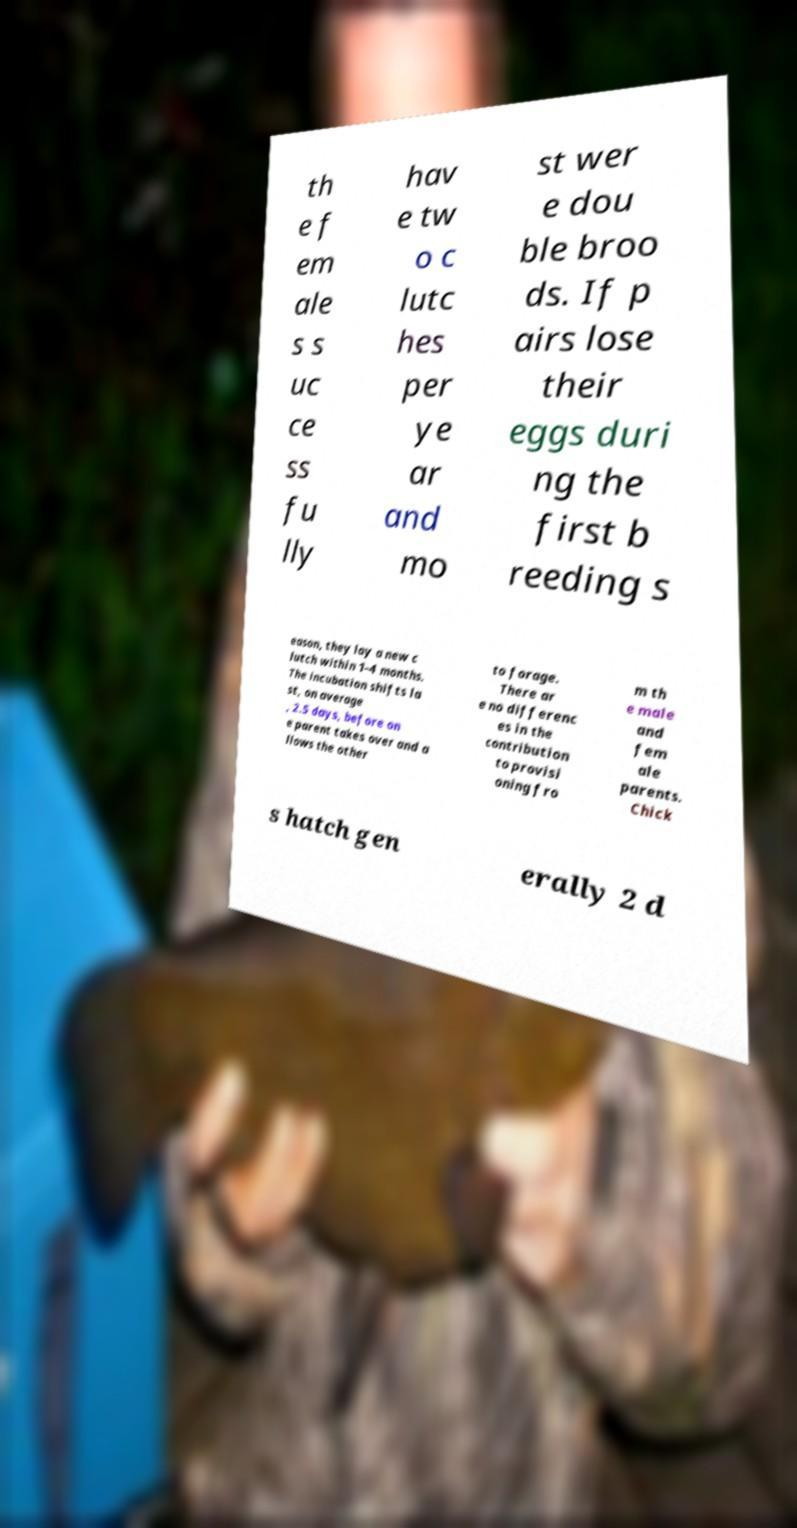What messages or text are displayed in this image? I need them in a readable, typed format. th e f em ale s s uc ce ss fu lly hav e tw o c lutc hes per ye ar and mo st wer e dou ble broo ds. If p airs lose their eggs duri ng the first b reeding s eason, they lay a new c lutch within 1–4 months. The incubation shifts la st, on average , 2.5 days, before on e parent takes over and a llows the other to forage. There ar e no differenc es in the contribution to provisi oning fro m th e male and fem ale parents. Chick s hatch gen erally 2 d 